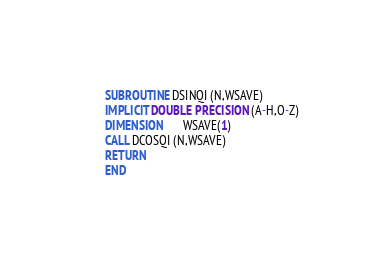<code> <loc_0><loc_0><loc_500><loc_500><_FORTRAN_>      SUBROUTINE DSINQI (N,WSAVE)
      IMPLICIT DOUBLE PRECISION (A-H,O-Z)
      DIMENSION       WSAVE(1)
      CALL DCOSQI (N,WSAVE)
      RETURN
      END
</code> 